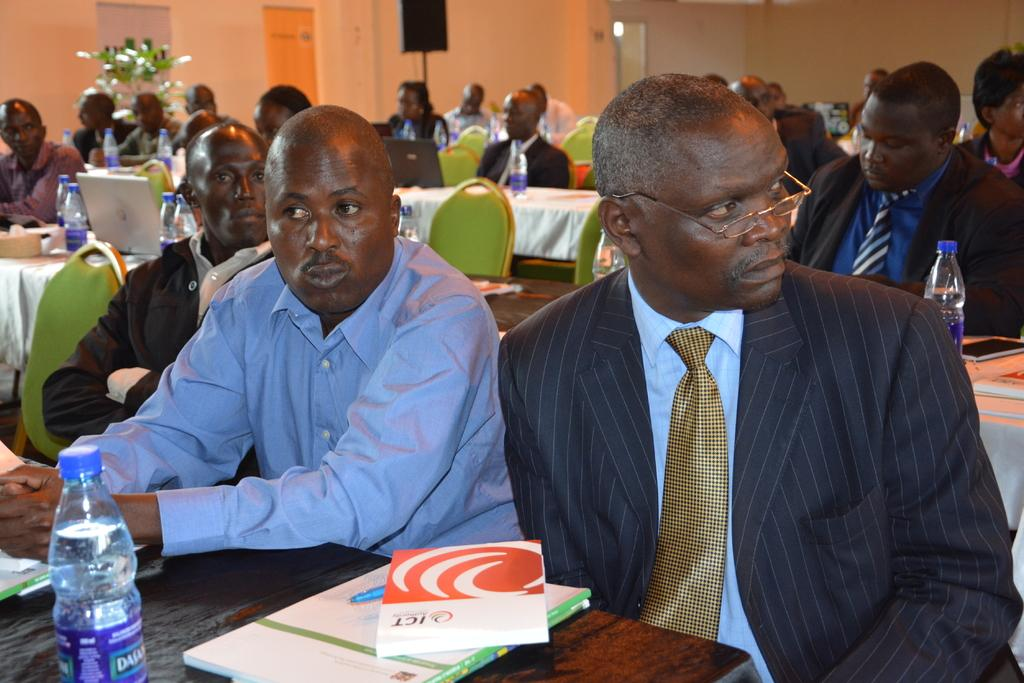What are the people in the image doing? The people in the image are sitting on chairs. What is present in the image besides the people? There is a table in the image. What can be seen on the table? There are laptops, books, and bottles on the table. What type of coach is sitting next to the woman in the image? There is no coach or woman present in the image. 